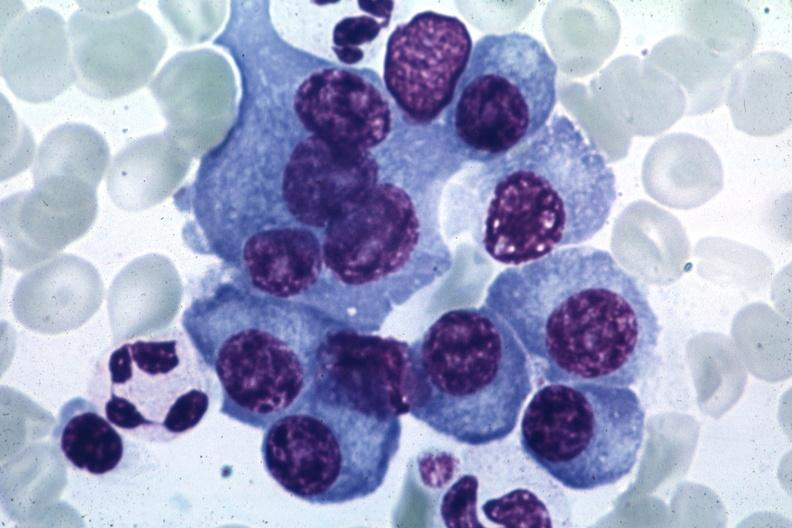s plasma cell present?
Answer the question using a single word or phrase. Yes 